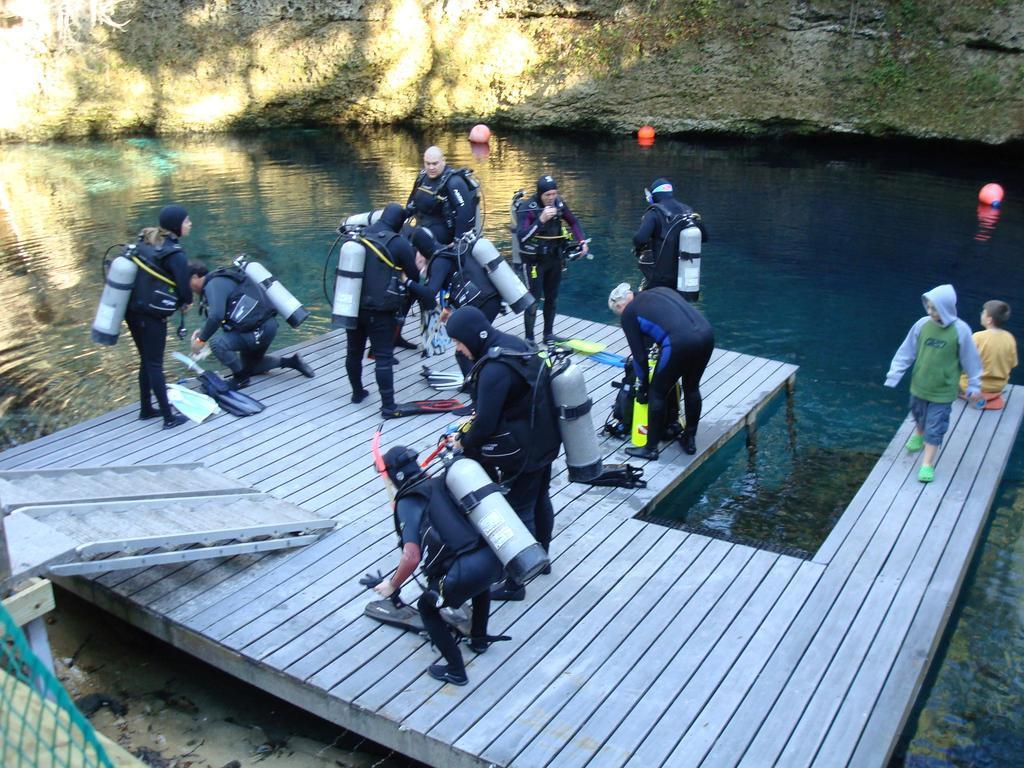How many people are in the image? There are people in the image, but the exact number is not specified. What are the people wearing? The people are wearing something, but the specific clothing is not described. What are the people holding? The people are holding something, but the objects are not identified. Where are the people located in the image? The people are on a wooden bridge in the image. What can be seen in the background of the image? There is water visible in the image, as well as rocks and other objects. Can you see a rabbit hopping on the wooden bridge in the image? No, there is no rabbit present in the image. What type of beast is lurking under the wooden bridge in the image? There is no beast present in the image; it only features people on a wooden bridge with water, rocks, and other objects visible in the background. 